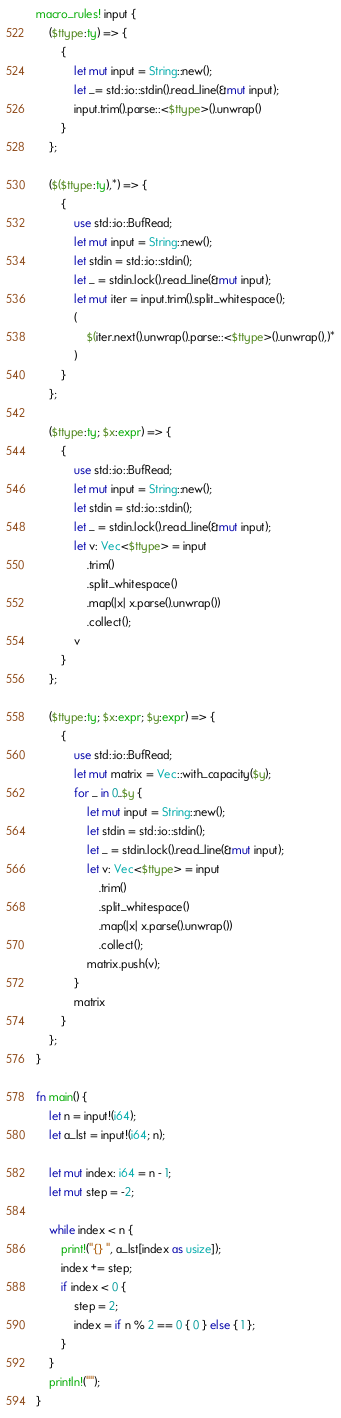Convert code to text. <code><loc_0><loc_0><loc_500><loc_500><_Rust_>macro_rules! input {
    ($ttype:ty) => {
        {
            let mut input = String::new();
            let _= std::io::stdin().read_line(&mut input);
            input.trim().parse::<$ttype>().unwrap()
        }
    };

    ($($ttype:ty),*) => {
        {
            use std::io::BufRead;
            let mut input = String::new();
            let stdin = std::io::stdin();
            let _ = stdin.lock().read_line(&mut input);
            let mut iter = input.trim().split_whitespace();
            (
                $(iter.next().unwrap().parse::<$ttype>().unwrap(),)*
            )
        }
    };

    ($ttype:ty; $x:expr) => {
        {
            use std::io::BufRead;
            let mut input = String::new();
            let stdin = std::io::stdin();
            let _ = stdin.lock().read_line(&mut input);
            let v: Vec<$ttype> = input
                .trim()
                .split_whitespace()
                .map(|x| x.parse().unwrap())
                .collect();
            v
        }
    };

    ($ttype:ty; $x:expr; $y:expr) => {
        {
            use std::io::BufRead;
            let mut matrix = Vec::with_capacity($y);
            for _ in 0..$y {
                let mut input = String::new();
                let stdin = std::io::stdin();
                let _ = stdin.lock().read_line(&mut input);
                let v: Vec<$ttype> = input
                    .trim()
                    .split_whitespace()
                    .map(|x| x.parse().unwrap())
                    .collect();
                matrix.push(v);
            }
            matrix
        }
    };
}

fn main() {
    let n = input!(i64);
    let a_lst = input!(i64; n);

    let mut index: i64 = n - 1;
    let mut step = -2;

    while index < n {
        print!("{} ", a_lst[index as usize]);
        index += step;
        if index < 0 {
            step = 2;
            index = if n % 2 == 0 { 0 } else { 1 };
        }
    }
    println!("");
}
</code> 